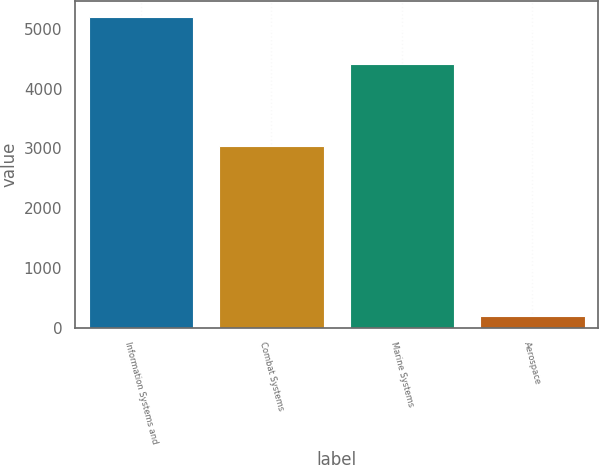<chart> <loc_0><loc_0><loc_500><loc_500><bar_chart><fcel>Information Systems and<fcel>Combat Systems<fcel>Marine Systems<fcel>Aerospace<nl><fcel>5201<fcel>3048<fcel>4407<fcel>199<nl></chart> 